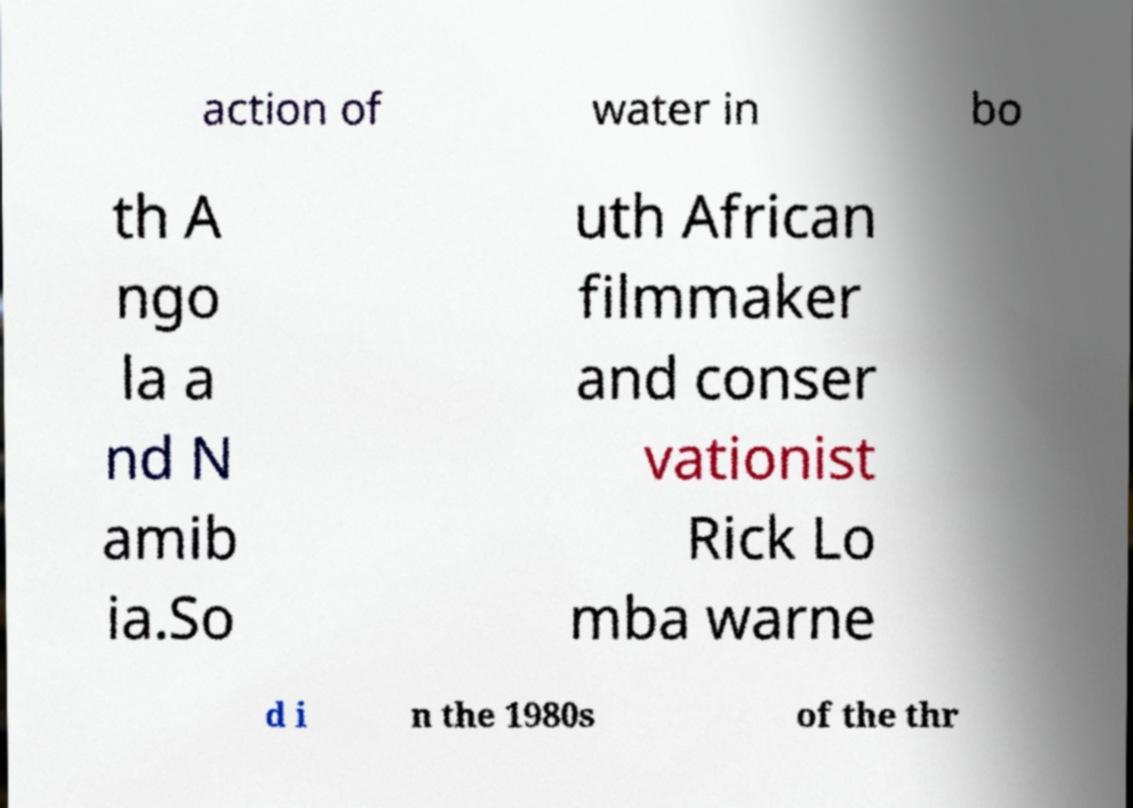Please read and relay the text visible in this image. What does it say? action of water in bo th A ngo la a nd N amib ia.So uth African filmmaker and conser vationist Rick Lo mba warne d i n the 1980s of the thr 